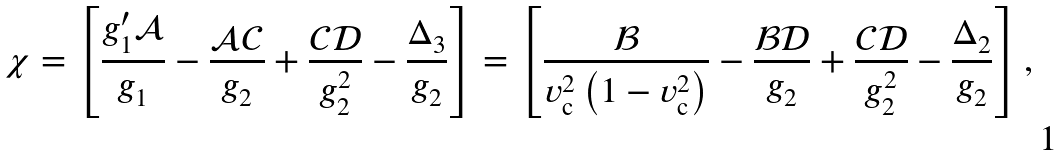Convert formula to latex. <formula><loc_0><loc_0><loc_500><loc_500>\chi = \left [ \frac { g _ { 1 } ^ { \prime } { \mathcal { A } } } { g _ { 1 } } - \frac { \mathcal { A C } } { g _ { 2 } } + \frac { \mathcal { C D } } { g _ { 2 } ^ { 2 } } - \frac { \Delta _ { 3 } } { g _ { 2 } } \right ] = \left [ \frac { \mathcal { B } } { v _ { \mathrm c } ^ { 2 } \left ( 1 - v _ { \mathrm c } ^ { 2 } \right ) } - \frac { \mathcal { B D } } { g _ { 2 } } + \frac { \mathcal { C D } } { g _ { 2 } ^ { 2 } } - \frac { \Delta _ { 2 } } { g _ { 2 } } \right ] ,</formula> 